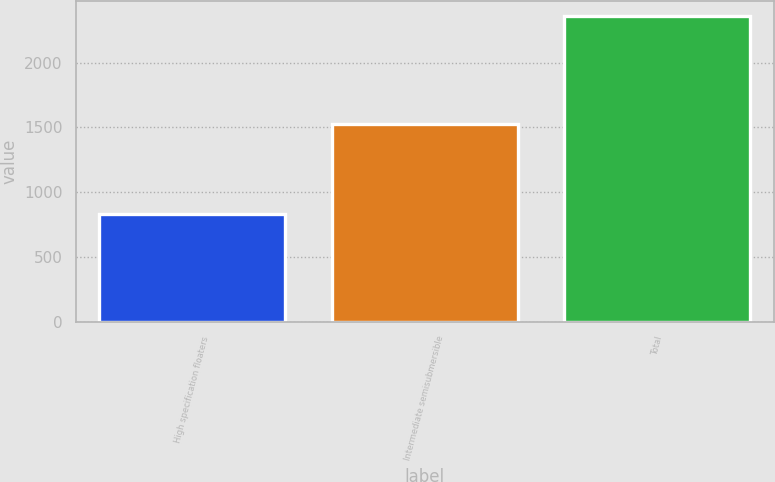Convert chart to OTSL. <chart><loc_0><loc_0><loc_500><loc_500><bar_chart><fcel>High specification floaters<fcel>Intermediate semisubmersible<fcel>Total<nl><fcel>832<fcel>1527<fcel>2359<nl></chart> 